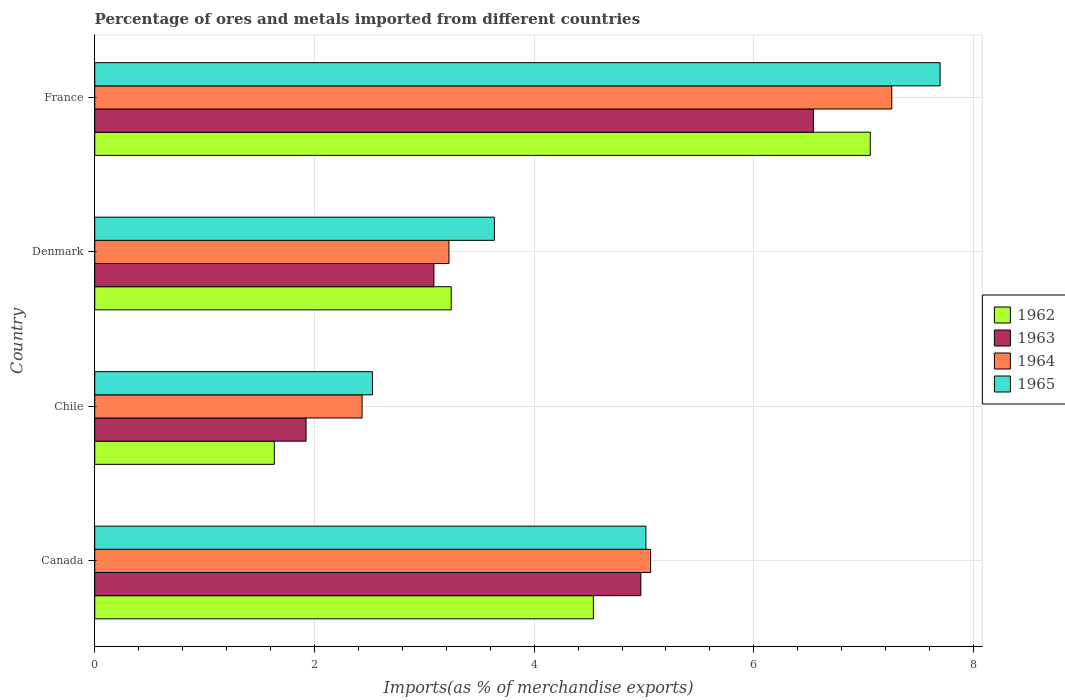Are the number of bars per tick equal to the number of legend labels?
Your answer should be very brief. Yes. Are the number of bars on each tick of the Y-axis equal?
Offer a terse response. Yes. How many bars are there on the 2nd tick from the top?
Ensure brevity in your answer.  4. How many bars are there on the 3rd tick from the bottom?
Your response must be concise. 4. What is the label of the 2nd group of bars from the top?
Ensure brevity in your answer.  Denmark. In how many cases, is the number of bars for a given country not equal to the number of legend labels?
Keep it short and to the point. 0. What is the percentage of imports to different countries in 1963 in France?
Make the answer very short. 6.54. Across all countries, what is the maximum percentage of imports to different countries in 1965?
Provide a short and direct response. 7.7. Across all countries, what is the minimum percentage of imports to different countries in 1962?
Make the answer very short. 1.63. In which country was the percentage of imports to different countries in 1965 maximum?
Give a very brief answer. France. What is the total percentage of imports to different countries in 1963 in the graph?
Keep it short and to the point. 16.52. What is the difference between the percentage of imports to different countries in 1963 in Chile and that in Denmark?
Keep it short and to the point. -1.16. What is the difference between the percentage of imports to different countries in 1962 in France and the percentage of imports to different countries in 1963 in Denmark?
Ensure brevity in your answer.  3.97. What is the average percentage of imports to different countries in 1963 per country?
Give a very brief answer. 4.13. What is the difference between the percentage of imports to different countries in 1965 and percentage of imports to different countries in 1963 in Denmark?
Give a very brief answer. 0.55. What is the ratio of the percentage of imports to different countries in 1964 in Denmark to that in France?
Keep it short and to the point. 0.44. Is the difference between the percentage of imports to different countries in 1965 in Canada and France greater than the difference between the percentage of imports to different countries in 1963 in Canada and France?
Your answer should be compact. No. What is the difference between the highest and the second highest percentage of imports to different countries in 1964?
Give a very brief answer. 2.19. What is the difference between the highest and the lowest percentage of imports to different countries in 1962?
Your response must be concise. 5.43. In how many countries, is the percentage of imports to different countries in 1964 greater than the average percentage of imports to different countries in 1964 taken over all countries?
Offer a terse response. 2. What does the 3rd bar from the top in Canada represents?
Keep it short and to the point. 1963. What does the 3rd bar from the bottom in Chile represents?
Give a very brief answer. 1964. Is it the case that in every country, the sum of the percentage of imports to different countries in 1965 and percentage of imports to different countries in 1964 is greater than the percentage of imports to different countries in 1962?
Give a very brief answer. Yes. Are all the bars in the graph horizontal?
Provide a succinct answer. Yes. How many countries are there in the graph?
Provide a short and direct response. 4. What is the difference between two consecutive major ticks on the X-axis?
Your response must be concise. 2. Are the values on the major ticks of X-axis written in scientific E-notation?
Provide a succinct answer. No. Does the graph contain any zero values?
Make the answer very short. No. Does the graph contain grids?
Your answer should be compact. Yes. Where does the legend appear in the graph?
Ensure brevity in your answer.  Center right. How are the legend labels stacked?
Provide a succinct answer. Vertical. What is the title of the graph?
Ensure brevity in your answer.  Percentage of ores and metals imported from different countries. Does "1967" appear as one of the legend labels in the graph?
Your answer should be very brief. No. What is the label or title of the X-axis?
Provide a succinct answer. Imports(as % of merchandise exports). What is the label or title of the Y-axis?
Offer a terse response. Country. What is the Imports(as % of merchandise exports) in 1962 in Canada?
Provide a short and direct response. 4.54. What is the Imports(as % of merchandise exports) in 1963 in Canada?
Ensure brevity in your answer.  4.97. What is the Imports(as % of merchandise exports) in 1964 in Canada?
Make the answer very short. 5.06. What is the Imports(as % of merchandise exports) in 1965 in Canada?
Offer a terse response. 5.02. What is the Imports(as % of merchandise exports) in 1962 in Chile?
Ensure brevity in your answer.  1.63. What is the Imports(as % of merchandise exports) of 1963 in Chile?
Your answer should be compact. 1.92. What is the Imports(as % of merchandise exports) in 1964 in Chile?
Keep it short and to the point. 2.43. What is the Imports(as % of merchandise exports) of 1965 in Chile?
Give a very brief answer. 2.53. What is the Imports(as % of merchandise exports) in 1962 in Denmark?
Your answer should be very brief. 3.25. What is the Imports(as % of merchandise exports) in 1963 in Denmark?
Your response must be concise. 3.09. What is the Imports(as % of merchandise exports) in 1964 in Denmark?
Give a very brief answer. 3.22. What is the Imports(as % of merchandise exports) of 1965 in Denmark?
Your answer should be compact. 3.64. What is the Imports(as % of merchandise exports) in 1962 in France?
Your answer should be very brief. 7.06. What is the Imports(as % of merchandise exports) in 1963 in France?
Your response must be concise. 6.54. What is the Imports(as % of merchandise exports) of 1964 in France?
Keep it short and to the point. 7.26. What is the Imports(as % of merchandise exports) of 1965 in France?
Your answer should be very brief. 7.7. Across all countries, what is the maximum Imports(as % of merchandise exports) of 1962?
Your answer should be very brief. 7.06. Across all countries, what is the maximum Imports(as % of merchandise exports) of 1963?
Offer a terse response. 6.54. Across all countries, what is the maximum Imports(as % of merchandise exports) in 1964?
Make the answer very short. 7.26. Across all countries, what is the maximum Imports(as % of merchandise exports) in 1965?
Provide a short and direct response. 7.7. Across all countries, what is the minimum Imports(as % of merchandise exports) of 1962?
Make the answer very short. 1.63. Across all countries, what is the minimum Imports(as % of merchandise exports) in 1963?
Your answer should be very brief. 1.92. Across all countries, what is the minimum Imports(as % of merchandise exports) in 1964?
Your response must be concise. 2.43. Across all countries, what is the minimum Imports(as % of merchandise exports) in 1965?
Ensure brevity in your answer.  2.53. What is the total Imports(as % of merchandise exports) in 1962 in the graph?
Offer a terse response. 16.48. What is the total Imports(as % of merchandise exports) in 1963 in the graph?
Your answer should be compact. 16.52. What is the total Imports(as % of merchandise exports) in 1964 in the graph?
Your answer should be compact. 17.97. What is the total Imports(as % of merchandise exports) of 1965 in the graph?
Ensure brevity in your answer.  18.88. What is the difference between the Imports(as % of merchandise exports) of 1962 in Canada and that in Chile?
Your answer should be compact. 2.9. What is the difference between the Imports(as % of merchandise exports) in 1963 in Canada and that in Chile?
Offer a terse response. 3.05. What is the difference between the Imports(as % of merchandise exports) in 1964 in Canada and that in Chile?
Your answer should be compact. 2.63. What is the difference between the Imports(as % of merchandise exports) of 1965 in Canada and that in Chile?
Give a very brief answer. 2.49. What is the difference between the Imports(as % of merchandise exports) of 1962 in Canada and that in Denmark?
Your answer should be very brief. 1.29. What is the difference between the Imports(as % of merchandise exports) of 1963 in Canada and that in Denmark?
Give a very brief answer. 1.88. What is the difference between the Imports(as % of merchandise exports) of 1964 in Canada and that in Denmark?
Ensure brevity in your answer.  1.84. What is the difference between the Imports(as % of merchandise exports) of 1965 in Canada and that in Denmark?
Ensure brevity in your answer.  1.38. What is the difference between the Imports(as % of merchandise exports) in 1962 in Canada and that in France?
Your answer should be compact. -2.52. What is the difference between the Imports(as % of merchandise exports) in 1963 in Canada and that in France?
Give a very brief answer. -1.57. What is the difference between the Imports(as % of merchandise exports) in 1964 in Canada and that in France?
Offer a terse response. -2.19. What is the difference between the Imports(as % of merchandise exports) of 1965 in Canada and that in France?
Give a very brief answer. -2.68. What is the difference between the Imports(as % of merchandise exports) in 1962 in Chile and that in Denmark?
Your answer should be very brief. -1.61. What is the difference between the Imports(as % of merchandise exports) of 1963 in Chile and that in Denmark?
Your answer should be very brief. -1.16. What is the difference between the Imports(as % of merchandise exports) in 1964 in Chile and that in Denmark?
Offer a very short reply. -0.79. What is the difference between the Imports(as % of merchandise exports) of 1965 in Chile and that in Denmark?
Offer a terse response. -1.11. What is the difference between the Imports(as % of merchandise exports) of 1962 in Chile and that in France?
Your response must be concise. -5.43. What is the difference between the Imports(as % of merchandise exports) in 1963 in Chile and that in France?
Your response must be concise. -4.62. What is the difference between the Imports(as % of merchandise exports) of 1964 in Chile and that in France?
Offer a terse response. -4.82. What is the difference between the Imports(as % of merchandise exports) of 1965 in Chile and that in France?
Your response must be concise. -5.17. What is the difference between the Imports(as % of merchandise exports) in 1962 in Denmark and that in France?
Give a very brief answer. -3.81. What is the difference between the Imports(as % of merchandise exports) of 1963 in Denmark and that in France?
Give a very brief answer. -3.45. What is the difference between the Imports(as % of merchandise exports) of 1964 in Denmark and that in France?
Provide a short and direct response. -4.03. What is the difference between the Imports(as % of merchandise exports) in 1965 in Denmark and that in France?
Provide a succinct answer. -4.06. What is the difference between the Imports(as % of merchandise exports) of 1962 in Canada and the Imports(as % of merchandise exports) of 1963 in Chile?
Provide a short and direct response. 2.62. What is the difference between the Imports(as % of merchandise exports) in 1962 in Canada and the Imports(as % of merchandise exports) in 1964 in Chile?
Ensure brevity in your answer.  2.11. What is the difference between the Imports(as % of merchandise exports) of 1962 in Canada and the Imports(as % of merchandise exports) of 1965 in Chile?
Give a very brief answer. 2.01. What is the difference between the Imports(as % of merchandise exports) of 1963 in Canada and the Imports(as % of merchandise exports) of 1964 in Chile?
Make the answer very short. 2.54. What is the difference between the Imports(as % of merchandise exports) of 1963 in Canada and the Imports(as % of merchandise exports) of 1965 in Chile?
Offer a very short reply. 2.44. What is the difference between the Imports(as % of merchandise exports) of 1964 in Canada and the Imports(as % of merchandise exports) of 1965 in Chile?
Your answer should be very brief. 2.53. What is the difference between the Imports(as % of merchandise exports) of 1962 in Canada and the Imports(as % of merchandise exports) of 1963 in Denmark?
Make the answer very short. 1.45. What is the difference between the Imports(as % of merchandise exports) in 1962 in Canada and the Imports(as % of merchandise exports) in 1964 in Denmark?
Keep it short and to the point. 1.31. What is the difference between the Imports(as % of merchandise exports) in 1962 in Canada and the Imports(as % of merchandise exports) in 1965 in Denmark?
Give a very brief answer. 0.9. What is the difference between the Imports(as % of merchandise exports) in 1963 in Canada and the Imports(as % of merchandise exports) in 1964 in Denmark?
Make the answer very short. 1.75. What is the difference between the Imports(as % of merchandise exports) of 1963 in Canada and the Imports(as % of merchandise exports) of 1965 in Denmark?
Offer a terse response. 1.33. What is the difference between the Imports(as % of merchandise exports) in 1964 in Canada and the Imports(as % of merchandise exports) in 1965 in Denmark?
Make the answer very short. 1.42. What is the difference between the Imports(as % of merchandise exports) of 1962 in Canada and the Imports(as % of merchandise exports) of 1963 in France?
Give a very brief answer. -2. What is the difference between the Imports(as % of merchandise exports) of 1962 in Canada and the Imports(as % of merchandise exports) of 1964 in France?
Offer a very short reply. -2.72. What is the difference between the Imports(as % of merchandise exports) in 1962 in Canada and the Imports(as % of merchandise exports) in 1965 in France?
Ensure brevity in your answer.  -3.16. What is the difference between the Imports(as % of merchandise exports) in 1963 in Canada and the Imports(as % of merchandise exports) in 1964 in France?
Keep it short and to the point. -2.28. What is the difference between the Imports(as % of merchandise exports) in 1963 in Canada and the Imports(as % of merchandise exports) in 1965 in France?
Offer a very short reply. -2.72. What is the difference between the Imports(as % of merchandise exports) of 1964 in Canada and the Imports(as % of merchandise exports) of 1965 in France?
Make the answer very short. -2.64. What is the difference between the Imports(as % of merchandise exports) of 1962 in Chile and the Imports(as % of merchandise exports) of 1963 in Denmark?
Make the answer very short. -1.45. What is the difference between the Imports(as % of merchandise exports) of 1962 in Chile and the Imports(as % of merchandise exports) of 1964 in Denmark?
Keep it short and to the point. -1.59. What is the difference between the Imports(as % of merchandise exports) of 1962 in Chile and the Imports(as % of merchandise exports) of 1965 in Denmark?
Offer a terse response. -2. What is the difference between the Imports(as % of merchandise exports) of 1963 in Chile and the Imports(as % of merchandise exports) of 1964 in Denmark?
Your response must be concise. -1.3. What is the difference between the Imports(as % of merchandise exports) of 1963 in Chile and the Imports(as % of merchandise exports) of 1965 in Denmark?
Provide a short and direct response. -1.71. What is the difference between the Imports(as % of merchandise exports) of 1964 in Chile and the Imports(as % of merchandise exports) of 1965 in Denmark?
Provide a succinct answer. -1.2. What is the difference between the Imports(as % of merchandise exports) in 1962 in Chile and the Imports(as % of merchandise exports) in 1963 in France?
Your answer should be compact. -4.91. What is the difference between the Imports(as % of merchandise exports) of 1962 in Chile and the Imports(as % of merchandise exports) of 1964 in France?
Offer a terse response. -5.62. What is the difference between the Imports(as % of merchandise exports) in 1962 in Chile and the Imports(as % of merchandise exports) in 1965 in France?
Provide a short and direct response. -6.06. What is the difference between the Imports(as % of merchandise exports) in 1963 in Chile and the Imports(as % of merchandise exports) in 1964 in France?
Your answer should be very brief. -5.33. What is the difference between the Imports(as % of merchandise exports) in 1963 in Chile and the Imports(as % of merchandise exports) in 1965 in France?
Keep it short and to the point. -5.77. What is the difference between the Imports(as % of merchandise exports) in 1964 in Chile and the Imports(as % of merchandise exports) in 1965 in France?
Keep it short and to the point. -5.26. What is the difference between the Imports(as % of merchandise exports) in 1962 in Denmark and the Imports(as % of merchandise exports) in 1963 in France?
Offer a very short reply. -3.3. What is the difference between the Imports(as % of merchandise exports) in 1962 in Denmark and the Imports(as % of merchandise exports) in 1964 in France?
Your answer should be very brief. -4.01. What is the difference between the Imports(as % of merchandise exports) in 1962 in Denmark and the Imports(as % of merchandise exports) in 1965 in France?
Offer a very short reply. -4.45. What is the difference between the Imports(as % of merchandise exports) in 1963 in Denmark and the Imports(as % of merchandise exports) in 1964 in France?
Your response must be concise. -4.17. What is the difference between the Imports(as % of merchandise exports) of 1963 in Denmark and the Imports(as % of merchandise exports) of 1965 in France?
Your response must be concise. -4.61. What is the difference between the Imports(as % of merchandise exports) in 1964 in Denmark and the Imports(as % of merchandise exports) in 1965 in France?
Your response must be concise. -4.47. What is the average Imports(as % of merchandise exports) in 1962 per country?
Give a very brief answer. 4.12. What is the average Imports(as % of merchandise exports) in 1963 per country?
Make the answer very short. 4.13. What is the average Imports(as % of merchandise exports) in 1964 per country?
Give a very brief answer. 4.49. What is the average Imports(as % of merchandise exports) of 1965 per country?
Offer a very short reply. 4.72. What is the difference between the Imports(as % of merchandise exports) in 1962 and Imports(as % of merchandise exports) in 1963 in Canada?
Ensure brevity in your answer.  -0.43. What is the difference between the Imports(as % of merchandise exports) of 1962 and Imports(as % of merchandise exports) of 1964 in Canada?
Your response must be concise. -0.52. What is the difference between the Imports(as % of merchandise exports) of 1962 and Imports(as % of merchandise exports) of 1965 in Canada?
Your response must be concise. -0.48. What is the difference between the Imports(as % of merchandise exports) in 1963 and Imports(as % of merchandise exports) in 1964 in Canada?
Keep it short and to the point. -0.09. What is the difference between the Imports(as % of merchandise exports) in 1963 and Imports(as % of merchandise exports) in 1965 in Canada?
Keep it short and to the point. -0.05. What is the difference between the Imports(as % of merchandise exports) in 1964 and Imports(as % of merchandise exports) in 1965 in Canada?
Give a very brief answer. 0.04. What is the difference between the Imports(as % of merchandise exports) of 1962 and Imports(as % of merchandise exports) of 1963 in Chile?
Offer a very short reply. -0.29. What is the difference between the Imports(as % of merchandise exports) in 1962 and Imports(as % of merchandise exports) in 1964 in Chile?
Provide a short and direct response. -0.8. What is the difference between the Imports(as % of merchandise exports) of 1962 and Imports(as % of merchandise exports) of 1965 in Chile?
Your answer should be compact. -0.89. What is the difference between the Imports(as % of merchandise exports) in 1963 and Imports(as % of merchandise exports) in 1964 in Chile?
Give a very brief answer. -0.51. What is the difference between the Imports(as % of merchandise exports) of 1963 and Imports(as % of merchandise exports) of 1965 in Chile?
Provide a succinct answer. -0.6. What is the difference between the Imports(as % of merchandise exports) in 1964 and Imports(as % of merchandise exports) in 1965 in Chile?
Your response must be concise. -0.09. What is the difference between the Imports(as % of merchandise exports) of 1962 and Imports(as % of merchandise exports) of 1963 in Denmark?
Provide a succinct answer. 0.16. What is the difference between the Imports(as % of merchandise exports) in 1962 and Imports(as % of merchandise exports) in 1964 in Denmark?
Provide a succinct answer. 0.02. What is the difference between the Imports(as % of merchandise exports) in 1962 and Imports(as % of merchandise exports) in 1965 in Denmark?
Ensure brevity in your answer.  -0.39. What is the difference between the Imports(as % of merchandise exports) in 1963 and Imports(as % of merchandise exports) in 1964 in Denmark?
Your answer should be very brief. -0.14. What is the difference between the Imports(as % of merchandise exports) of 1963 and Imports(as % of merchandise exports) of 1965 in Denmark?
Your response must be concise. -0.55. What is the difference between the Imports(as % of merchandise exports) in 1964 and Imports(as % of merchandise exports) in 1965 in Denmark?
Give a very brief answer. -0.41. What is the difference between the Imports(as % of merchandise exports) in 1962 and Imports(as % of merchandise exports) in 1963 in France?
Keep it short and to the point. 0.52. What is the difference between the Imports(as % of merchandise exports) of 1962 and Imports(as % of merchandise exports) of 1964 in France?
Ensure brevity in your answer.  -0.2. What is the difference between the Imports(as % of merchandise exports) of 1962 and Imports(as % of merchandise exports) of 1965 in France?
Keep it short and to the point. -0.64. What is the difference between the Imports(as % of merchandise exports) of 1963 and Imports(as % of merchandise exports) of 1964 in France?
Provide a succinct answer. -0.71. What is the difference between the Imports(as % of merchandise exports) of 1963 and Imports(as % of merchandise exports) of 1965 in France?
Offer a terse response. -1.15. What is the difference between the Imports(as % of merchandise exports) in 1964 and Imports(as % of merchandise exports) in 1965 in France?
Provide a short and direct response. -0.44. What is the ratio of the Imports(as % of merchandise exports) in 1962 in Canada to that in Chile?
Offer a terse response. 2.78. What is the ratio of the Imports(as % of merchandise exports) of 1963 in Canada to that in Chile?
Your answer should be very brief. 2.58. What is the ratio of the Imports(as % of merchandise exports) in 1964 in Canada to that in Chile?
Your response must be concise. 2.08. What is the ratio of the Imports(as % of merchandise exports) in 1965 in Canada to that in Chile?
Your answer should be compact. 1.99. What is the ratio of the Imports(as % of merchandise exports) of 1962 in Canada to that in Denmark?
Keep it short and to the point. 1.4. What is the ratio of the Imports(as % of merchandise exports) in 1963 in Canada to that in Denmark?
Make the answer very short. 1.61. What is the ratio of the Imports(as % of merchandise exports) in 1964 in Canada to that in Denmark?
Offer a very short reply. 1.57. What is the ratio of the Imports(as % of merchandise exports) of 1965 in Canada to that in Denmark?
Your answer should be compact. 1.38. What is the ratio of the Imports(as % of merchandise exports) in 1962 in Canada to that in France?
Provide a short and direct response. 0.64. What is the ratio of the Imports(as % of merchandise exports) in 1963 in Canada to that in France?
Your answer should be very brief. 0.76. What is the ratio of the Imports(as % of merchandise exports) in 1964 in Canada to that in France?
Ensure brevity in your answer.  0.7. What is the ratio of the Imports(as % of merchandise exports) of 1965 in Canada to that in France?
Your answer should be very brief. 0.65. What is the ratio of the Imports(as % of merchandise exports) of 1962 in Chile to that in Denmark?
Make the answer very short. 0.5. What is the ratio of the Imports(as % of merchandise exports) in 1963 in Chile to that in Denmark?
Give a very brief answer. 0.62. What is the ratio of the Imports(as % of merchandise exports) of 1964 in Chile to that in Denmark?
Offer a very short reply. 0.75. What is the ratio of the Imports(as % of merchandise exports) in 1965 in Chile to that in Denmark?
Offer a terse response. 0.69. What is the ratio of the Imports(as % of merchandise exports) of 1962 in Chile to that in France?
Provide a succinct answer. 0.23. What is the ratio of the Imports(as % of merchandise exports) of 1963 in Chile to that in France?
Provide a short and direct response. 0.29. What is the ratio of the Imports(as % of merchandise exports) in 1964 in Chile to that in France?
Give a very brief answer. 0.34. What is the ratio of the Imports(as % of merchandise exports) in 1965 in Chile to that in France?
Offer a very short reply. 0.33. What is the ratio of the Imports(as % of merchandise exports) of 1962 in Denmark to that in France?
Offer a terse response. 0.46. What is the ratio of the Imports(as % of merchandise exports) of 1963 in Denmark to that in France?
Provide a short and direct response. 0.47. What is the ratio of the Imports(as % of merchandise exports) in 1964 in Denmark to that in France?
Give a very brief answer. 0.44. What is the ratio of the Imports(as % of merchandise exports) of 1965 in Denmark to that in France?
Offer a very short reply. 0.47. What is the difference between the highest and the second highest Imports(as % of merchandise exports) of 1962?
Your answer should be compact. 2.52. What is the difference between the highest and the second highest Imports(as % of merchandise exports) of 1963?
Provide a short and direct response. 1.57. What is the difference between the highest and the second highest Imports(as % of merchandise exports) in 1964?
Offer a very short reply. 2.19. What is the difference between the highest and the second highest Imports(as % of merchandise exports) in 1965?
Give a very brief answer. 2.68. What is the difference between the highest and the lowest Imports(as % of merchandise exports) of 1962?
Your answer should be compact. 5.43. What is the difference between the highest and the lowest Imports(as % of merchandise exports) of 1963?
Offer a very short reply. 4.62. What is the difference between the highest and the lowest Imports(as % of merchandise exports) of 1964?
Offer a terse response. 4.82. What is the difference between the highest and the lowest Imports(as % of merchandise exports) of 1965?
Ensure brevity in your answer.  5.17. 